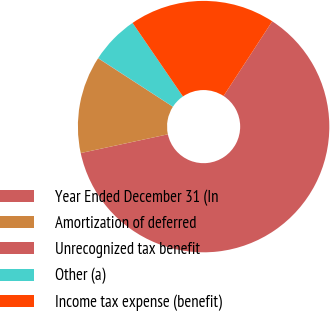Convert chart. <chart><loc_0><loc_0><loc_500><loc_500><pie_chart><fcel>Year Ended December 31 (In<fcel>Amortization of deferred<fcel>Unrecognized tax benefit<fcel>Other (a)<fcel>Income tax expense (benefit)<nl><fcel>62.43%<fcel>12.51%<fcel>0.03%<fcel>6.27%<fcel>18.75%<nl></chart> 